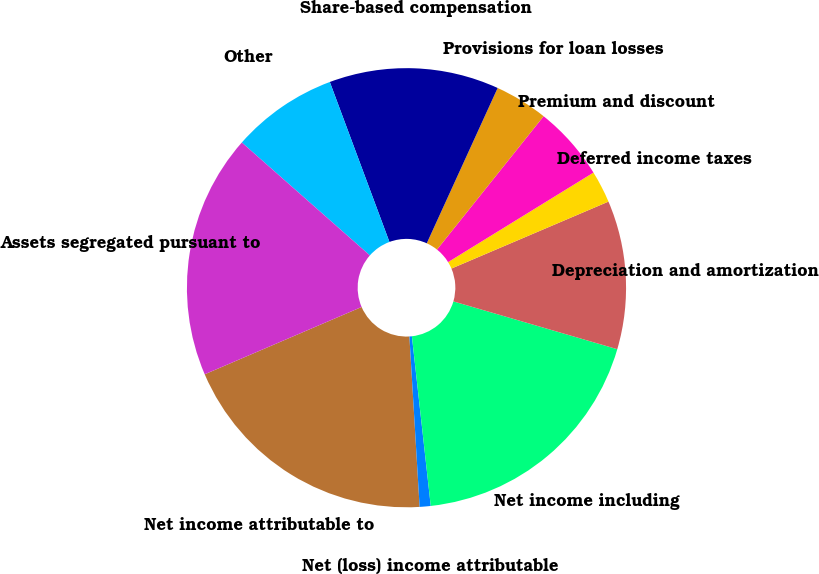Convert chart. <chart><loc_0><loc_0><loc_500><loc_500><pie_chart><fcel>Net income attributable to<fcel>Net (loss) income attributable<fcel>Net income including<fcel>Depreciation and amortization<fcel>Deferred income taxes<fcel>Premium and discount<fcel>Provisions for loan losses<fcel>Share-based compensation<fcel>Other<fcel>Assets segregated pursuant to<nl><fcel>19.5%<fcel>0.81%<fcel>18.72%<fcel>10.93%<fcel>2.37%<fcel>5.48%<fcel>3.92%<fcel>12.49%<fcel>7.82%<fcel>17.95%<nl></chart> 